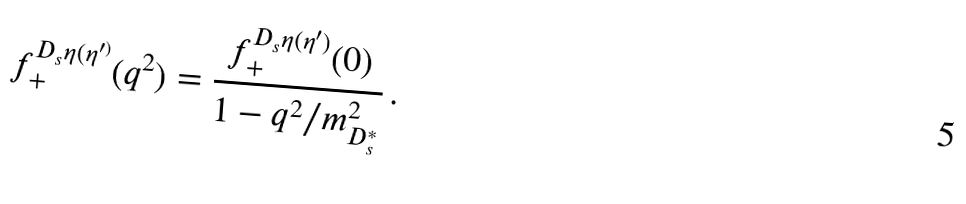Convert formula to latex. <formula><loc_0><loc_0><loc_500><loc_500>f _ { + } ^ { D _ { s } \eta ( \eta ^ { \prime ) } } ( q ^ { 2 } ) = { \frac { f _ { + } ^ { D _ { s } \eta ( \eta ^ { \prime } ) } ( 0 ) } { 1 - q ^ { 2 } / m _ { D _ { s } ^ { * } } ^ { 2 } } } \, .</formula> 